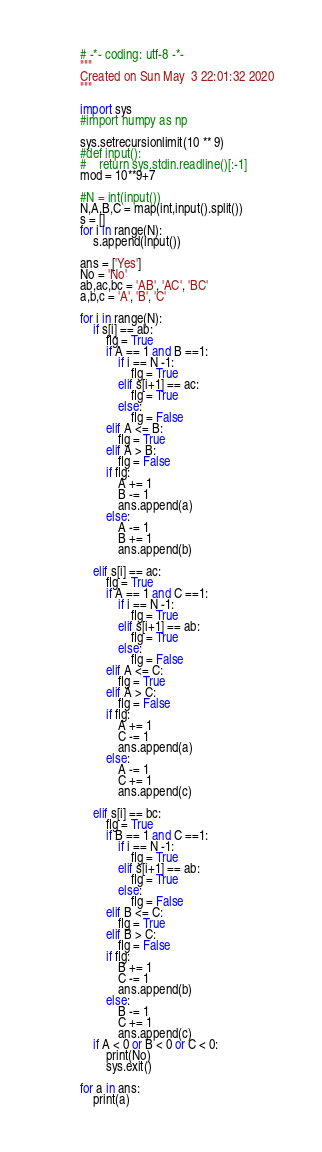Convert code to text. <code><loc_0><loc_0><loc_500><loc_500><_Python_># -*- coding: utf-8 -*-
"""
Created on Sun May  3 22:01:32 2020
"""

import sys
#import numpy as np

sys.setrecursionlimit(10 ** 9)
#def input():
#    return sys.stdin.readline()[:-1]
mod = 10**9+7

#N = int(input())
N,A,B,C = map(int,input().split())
s = []
for i in range(N):
    s.append(input())

ans = ['Yes']
No = 'No'
ab,ac,bc = 'AB', 'AC', 'BC'
a,b,c = 'A', 'B', 'C'

for i in range(N):
    if s[i] == ab:
        flg = True
        if A == 1 and B ==1:
            if i == N -1:
                flg = True
            elif s[i+1] == ac:
                flg = True
            else:
                flg = False
        elif A <= B:
            flg = True
        elif A > B:
            flg = False
        if flg:
            A += 1
            B -= 1
            ans.append(a)
        else:
            A -= 1
            B += 1
            ans.append(b)

    elif s[i] == ac:
        flg = True
        if A == 1 and C ==1:
            if i == N -1:
                flg = True
            elif s[i+1] == ab:
                flg = True
            else:
                flg = False
        elif A <= C:
            flg = True
        elif A > C:
            flg = False
        if flg:
            A += 1
            C -= 1
            ans.append(a)
        else:
            A -= 1
            C += 1
            ans.append(c)

    elif s[i] == bc:
        flg = True
        if B == 1 and C ==1:
            if i == N -1:
                flg = True
            elif s[i+1] == ab:
                flg = True
            else:
                flg = False
        elif B <= C:
            flg = True
        elif B > C:
            flg = False
        if flg:
            B += 1
            C -= 1
            ans.append(b)
        else:
            B -= 1
            C += 1
            ans.append(c)
    if A < 0 or B < 0 or C < 0:
        print(No)
        sys.exit()

for a in ans:
    print(a)


</code> 